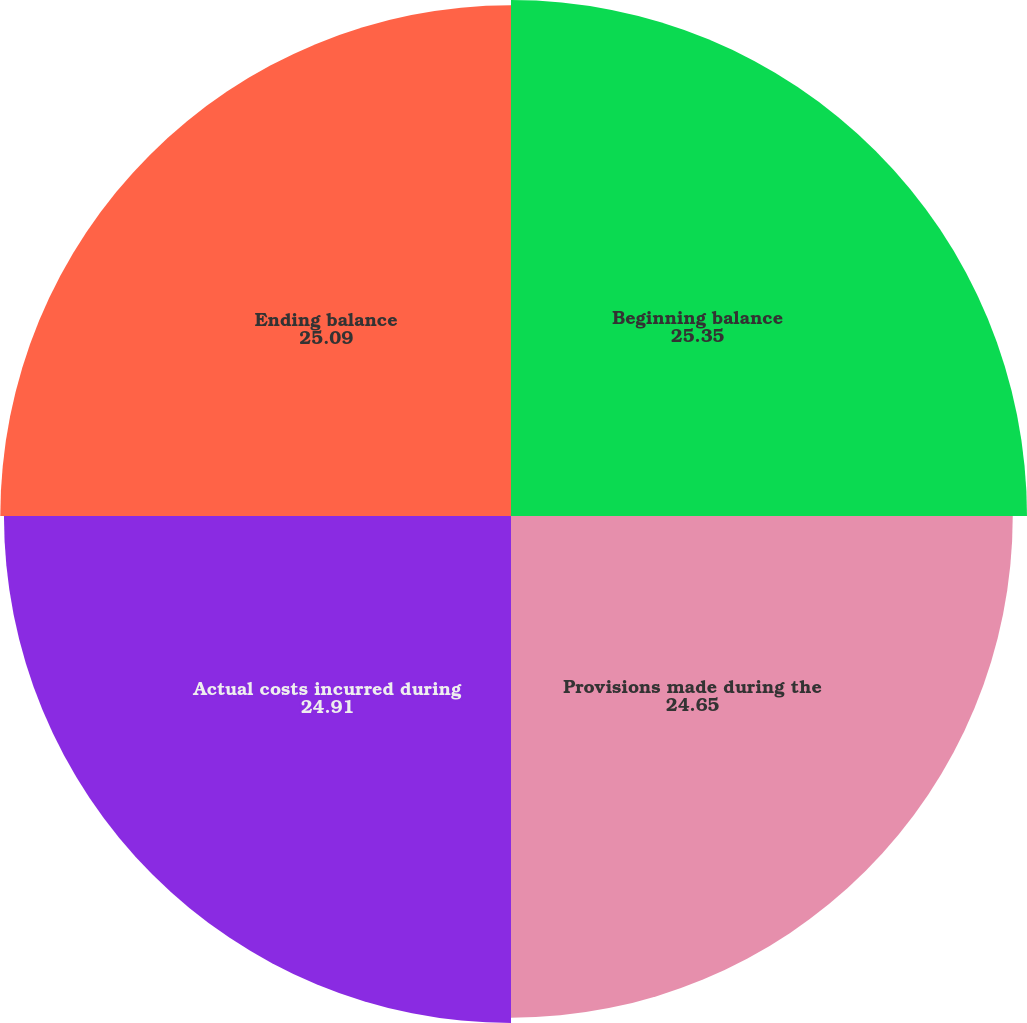<chart> <loc_0><loc_0><loc_500><loc_500><pie_chart><fcel>Beginning balance<fcel>Provisions made during the<fcel>Actual costs incurred during<fcel>Ending balance<nl><fcel>25.35%<fcel>24.65%<fcel>24.91%<fcel>25.09%<nl></chart> 